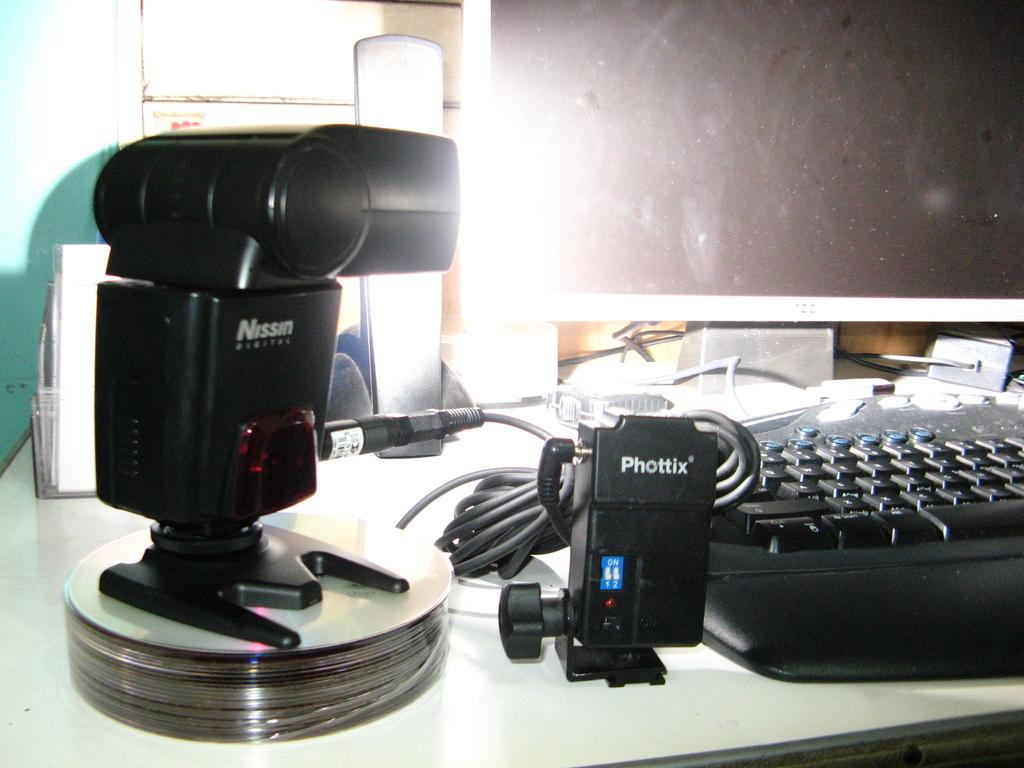<image>
Present a compact description of the photo's key features. A Nissin Digital camera and a Phottix sit in front of a computer. 